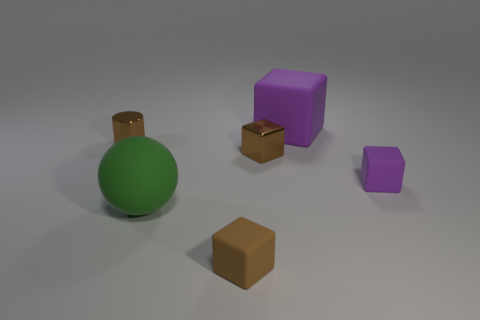What is the shape of the tiny object in front of the green sphere?
Your answer should be compact. Cube. What is the material of the big object in front of the large object that is behind the green rubber thing?
Make the answer very short. Rubber. Is the number of green matte objects that are right of the big purple rubber object greater than the number of tiny metallic cylinders?
Offer a terse response. No. How many other things are the same color as the metal cylinder?
Your answer should be very brief. 2. What is the shape of the purple thing that is the same size as the brown rubber object?
Ensure brevity in your answer.  Cube. There is a small block that is in front of the big object that is in front of the tiny purple matte cube; what number of small brown cubes are on the right side of it?
Provide a succinct answer. 1. How many rubber objects are green things or small brown cylinders?
Your response must be concise. 1. What is the color of the thing that is both left of the tiny brown matte thing and behind the large matte sphere?
Provide a short and direct response. Brown. Does the brown cube that is in front of the green matte ball have the same size as the tiny metallic block?
Offer a very short reply. Yes. How many objects are small rubber cubes in front of the small purple cube or gray balls?
Give a very brief answer. 1. 